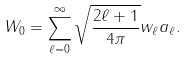<formula> <loc_0><loc_0><loc_500><loc_500>W _ { 0 } = \sum _ { \ell = 0 } ^ { \infty } { \sqrt { \frac { 2 \ell + 1 } { 4 \pi } } w _ { \ell } a _ { \ell } } .</formula> 